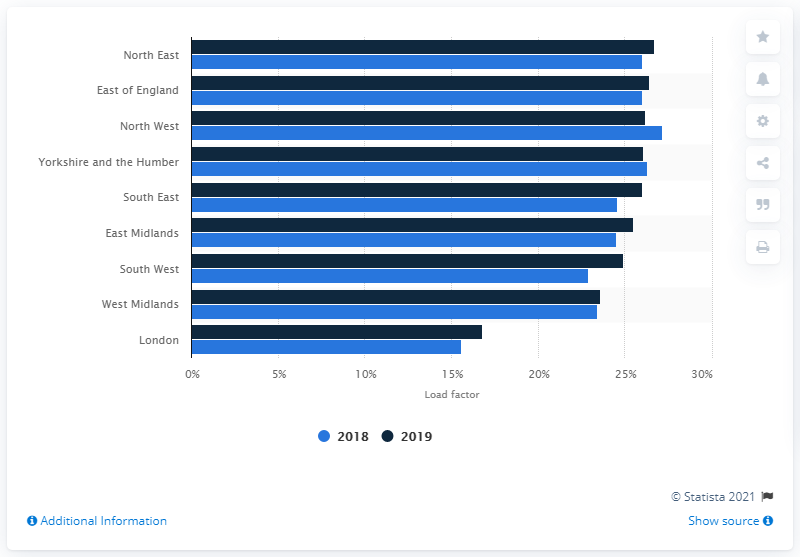Identify some key points in this picture. The load factor of wind onshore in South West in 2019 was 24.9%. According to the data, the North East region had the highest onshore wind energy load factor in England in 2019. 